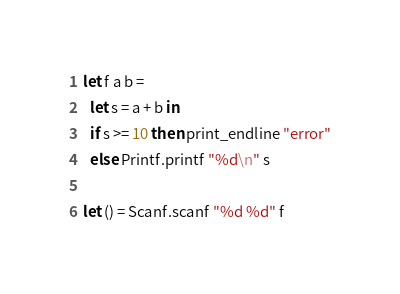Convert code to text. <code><loc_0><loc_0><loc_500><loc_500><_OCaml_>let f a b =
  let s = a + b in
  if s >= 10 then print_endline "error"
  else Printf.printf "%d\n" s

let () = Scanf.scanf "%d %d" f</code> 